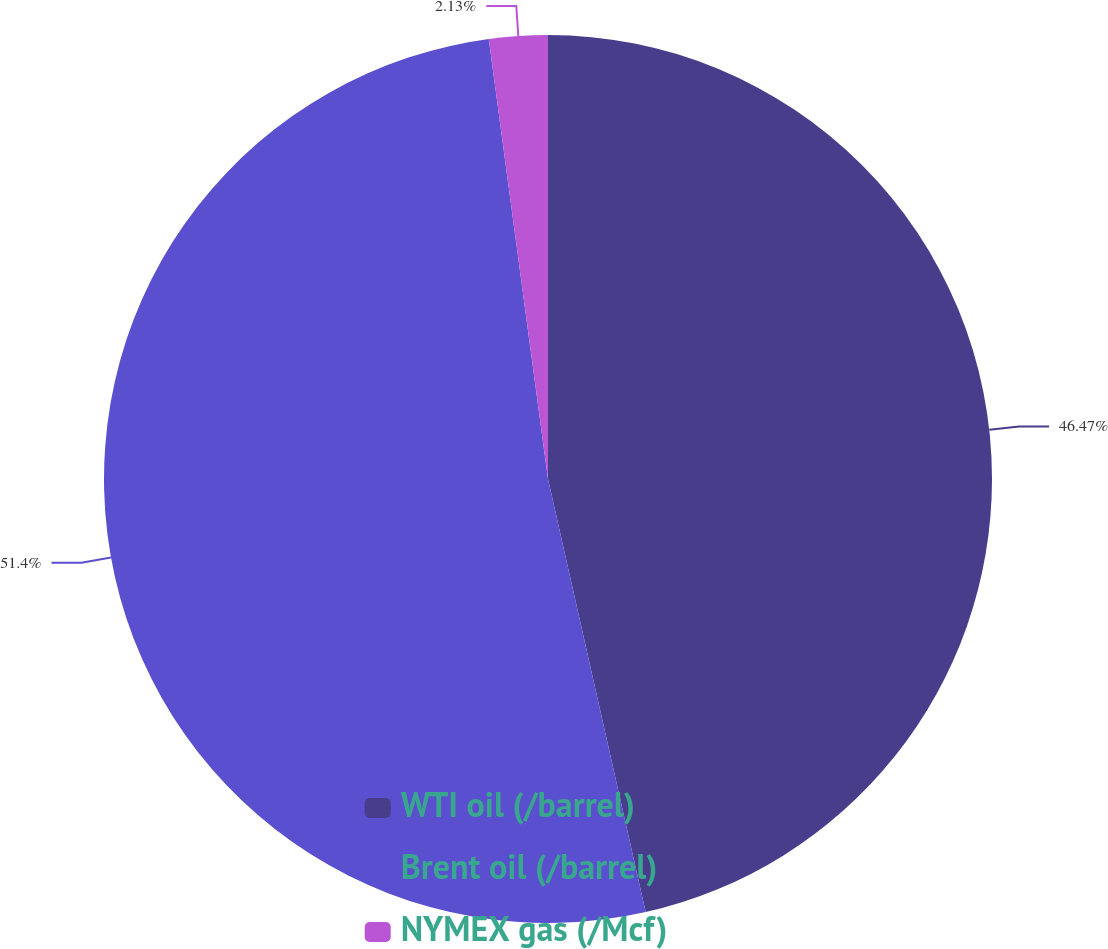Convert chart to OTSL. <chart><loc_0><loc_0><loc_500><loc_500><pie_chart><fcel>WTI oil (/barrel)<fcel>Brent oil (/barrel)<fcel>NYMEX gas (/Mcf)<nl><fcel>46.47%<fcel>51.4%<fcel>2.13%<nl></chart> 